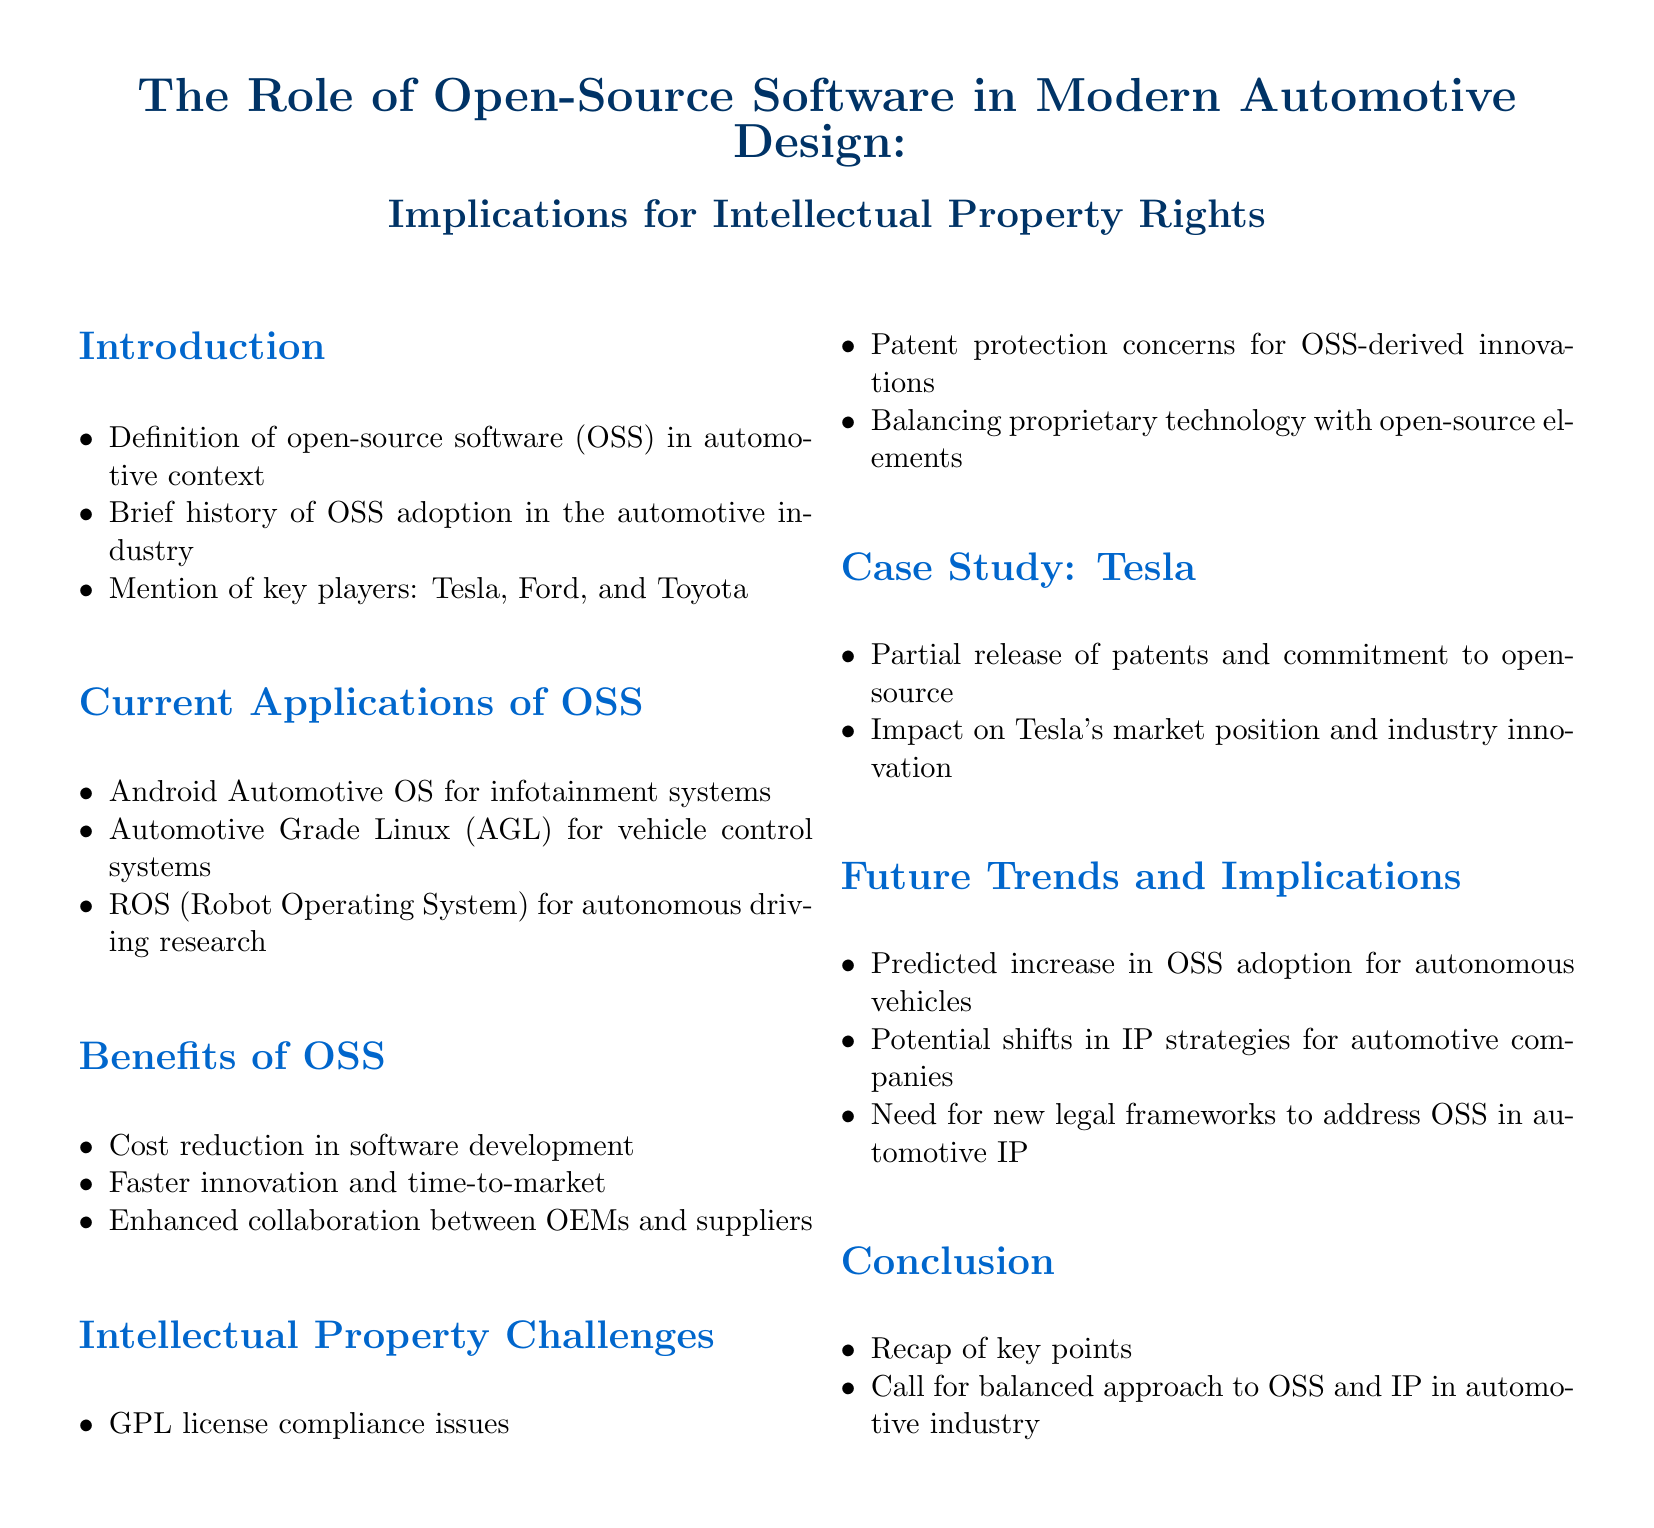What is the title of the document? The title is the primary heading of the document and summarizes its focus, which is mentioned at the beginning.
Answer: The Role of Open-Source Software in Modern Automotive Design: Implications for Intellectual Property Rights Who are the key players mentioned in the introduction? The key players are specifically noted in the introduction section as significant contributors to the topic discussed.
Answer: Tesla, Ford, and Toyota What is one application of open-source software in automotive design? This question seeks specific examples of how OSS is applied in the automotive context, as listed in the document.
Answer: Android Automotive OS for infotainment systems What benefit of OSS is mentioned in the document? The benefits are categorized, and this question aims to identify one specific advantage noted in the benefits section.
Answer: Cost reduction in software development What is a challenge related to intellectual property mentioned? This question looks for specific challenges outlined under the intellectual property challenges section in the document.
Answer: GPL license compliance issues What future trend is predicted in relation to OSS in automotive design? This question seeks to know what future developments are anticipated regarding OSS's role in the industry, as described in the document.
Answer: Predicted increase in OSS adoption for autonomous vehicles What does the case study on Tesla illustrate? The case study section highlights specific actions taken by Tesla and their implications, which this question aims to summarize.
Answer: Partial release of patents and commitment to open-source What does the conclusion call for regarding OSS and IP? This question seeks to understand the overarching message or action suggested in the conclusion section of the document.
Answer: Call for balanced approach to OSS and IP in automotive industry 